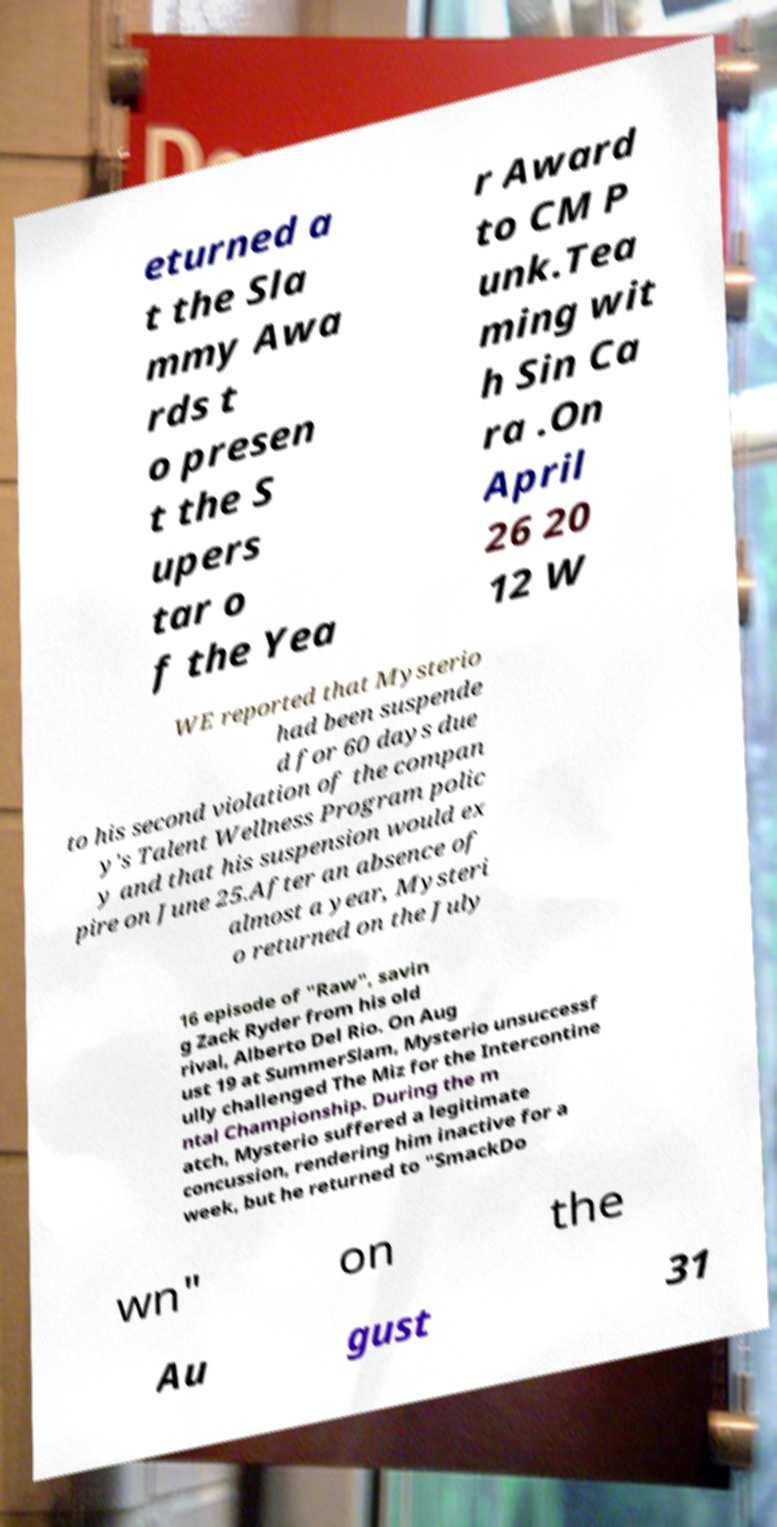Can you accurately transcribe the text from the provided image for me? eturned a t the Sla mmy Awa rds t o presen t the S upers tar o f the Yea r Award to CM P unk.Tea ming wit h Sin Ca ra .On April 26 20 12 W WE reported that Mysterio had been suspende d for 60 days due to his second violation of the compan y's Talent Wellness Program polic y and that his suspension would ex pire on June 25.After an absence of almost a year, Mysteri o returned on the July 16 episode of "Raw", savin g Zack Ryder from his old rival, Alberto Del Rio. On Aug ust 19 at SummerSlam, Mysterio unsuccessf ully challenged The Miz for the Intercontine ntal Championship. During the m atch, Mysterio suffered a legitimate concussion, rendering him inactive for a week, but he returned to "SmackDo wn" on the Au gust 31 